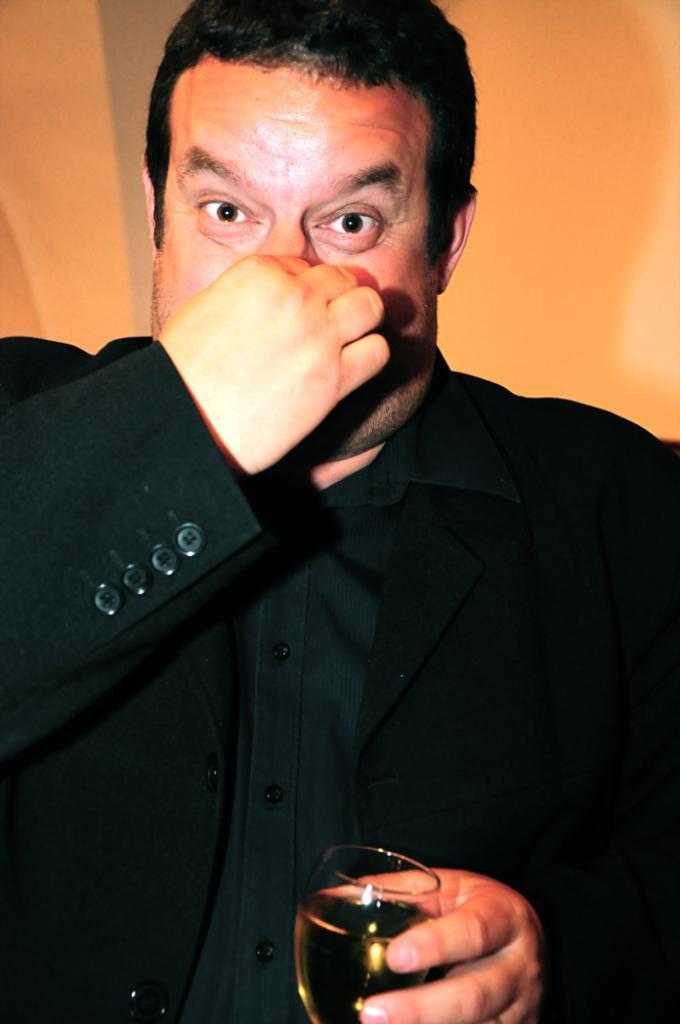Could you give a brief overview of what you see in this image? In this picture we can see a person, he is wearing a suit and holding a wine glass in his hand, and at the back there is the wall. 